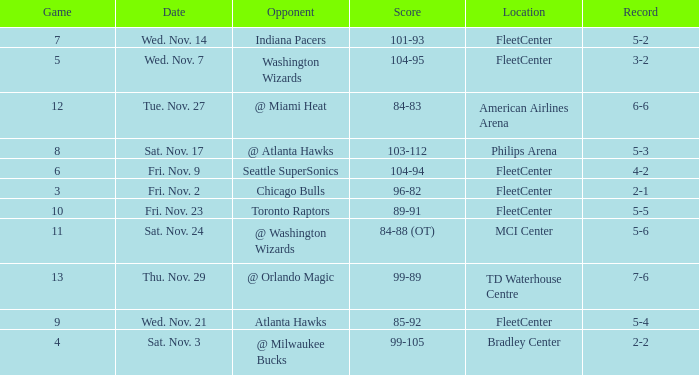How many games have a score of 85-92? 1.0. 